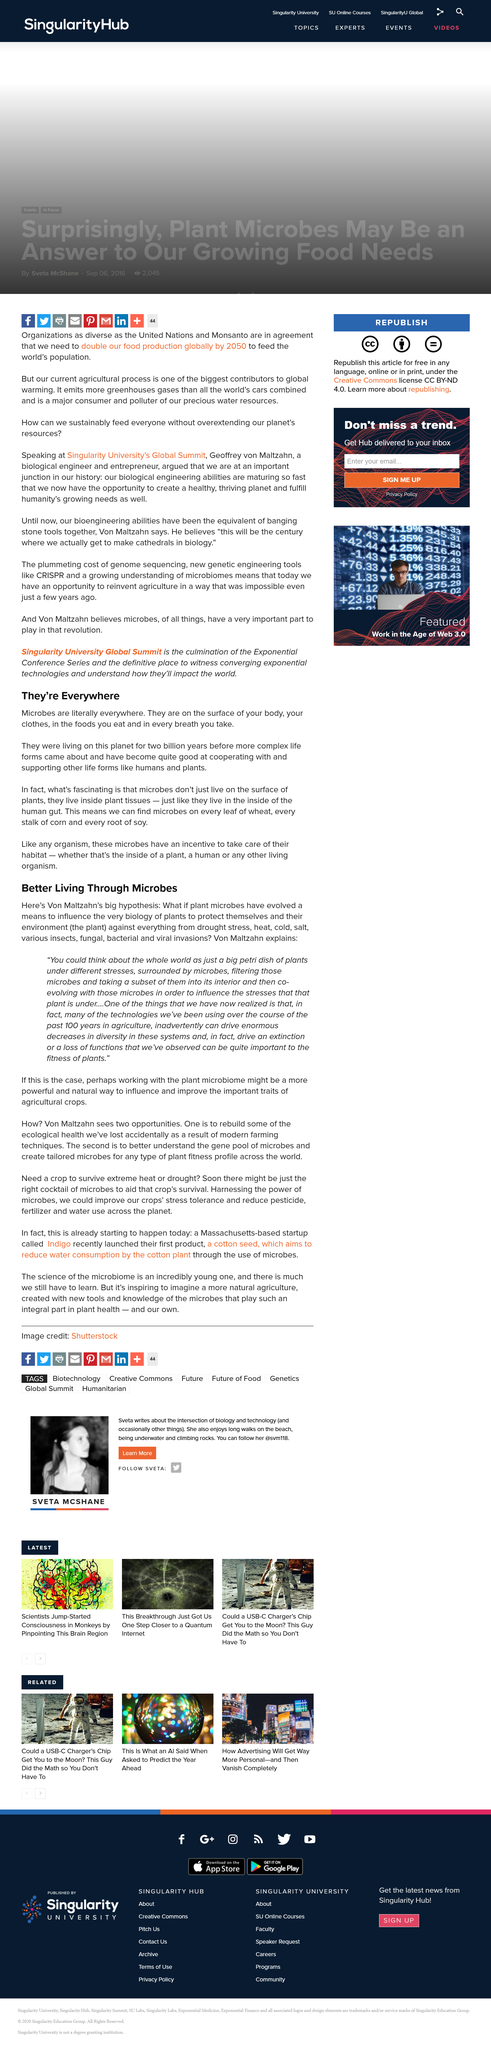Point out several critical features in this image. Yes, we have microbes on our bodies. Microbes can be found in virtually every environment on Earth, including in the air we breathe, the water we drink, and on the surfaces and in the soil that surrounds us. They are an essential component of the natural world, playing important roles in the cycling of nutrients and the regulation of ecosystem function. Despite their ubiquity, however, many people remain unaware of the prevalence and importance of microbes in our lives. For two billion years, microbes were the only living forms on this planet before complex life forms emerged. 